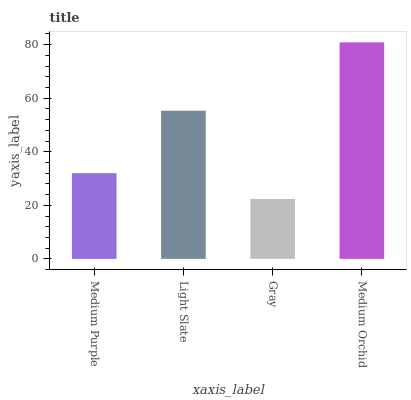Is Gray the minimum?
Answer yes or no. Yes. Is Medium Orchid the maximum?
Answer yes or no. Yes. Is Light Slate the minimum?
Answer yes or no. No. Is Light Slate the maximum?
Answer yes or no. No. Is Light Slate greater than Medium Purple?
Answer yes or no. Yes. Is Medium Purple less than Light Slate?
Answer yes or no. Yes. Is Medium Purple greater than Light Slate?
Answer yes or no. No. Is Light Slate less than Medium Purple?
Answer yes or no. No. Is Light Slate the high median?
Answer yes or no. Yes. Is Medium Purple the low median?
Answer yes or no. Yes. Is Gray the high median?
Answer yes or no. No. Is Light Slate the low median?
Answer yes or no. No. 